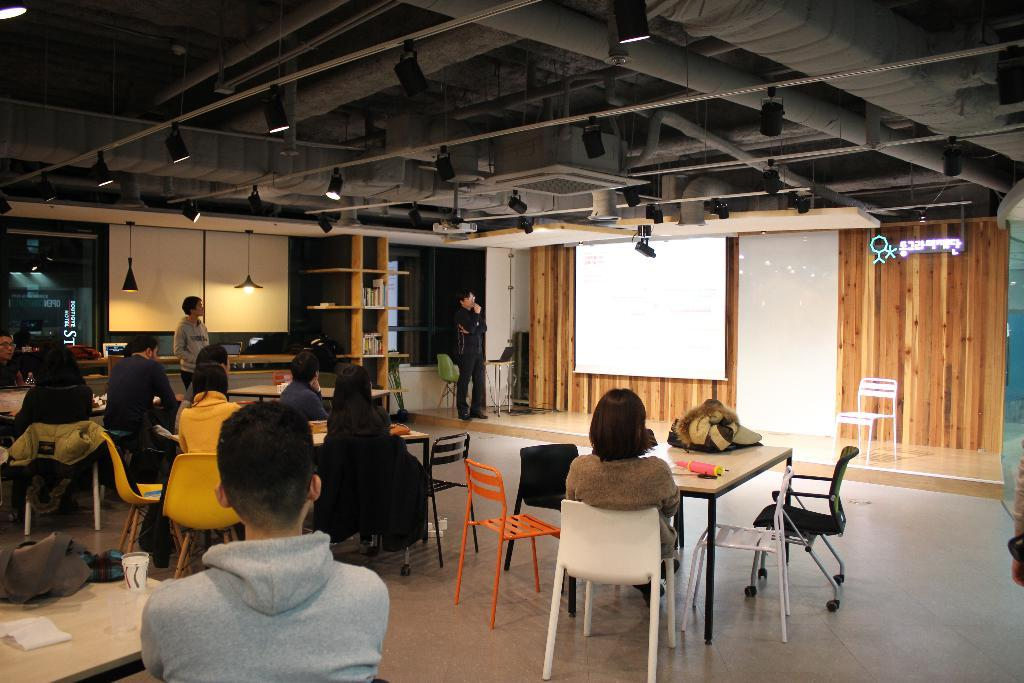What are the persons in the image doing? Some persons are sitting on chairs, while others are standing. What type of furniture is present in the image? Chairs and tables are present in the image. What can be seen in the background of the image? There is a wall and a screen in the background. What part of the room is visible? The floor is visible in the image. How many kittens are playing on the chair in the image? There are no kittens present in the image; only persons are visible. What type of chair is the kitten sitting on in the image? There is no chair or kitten present in the image. 